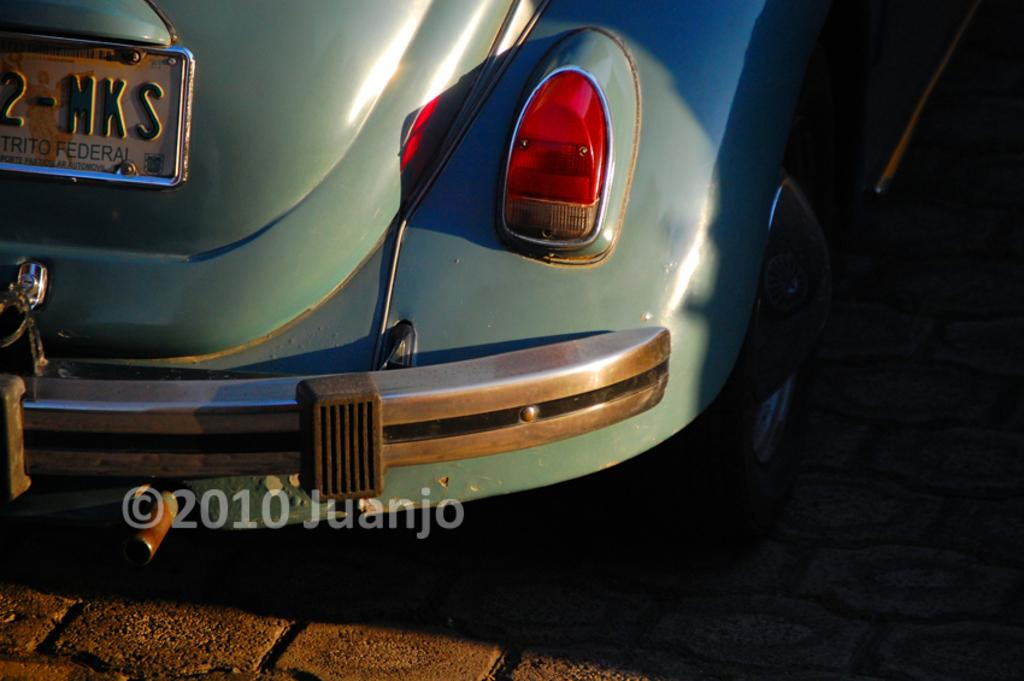What is the main subject of the image? The main subject of the image is a car. Can you describe anything else visible in the image? Yes, there is writing on a board in the top left side of the image. Is there any additional information or branding present in the image? Yes, there is a watermark on the bottom side of the image. How many fans are visible in the image? There are no fans present in the image. What type of books can be seen on the car's dashboard? There are no books visible in the image, as it only features a car, writing on a board, and a watermark. 